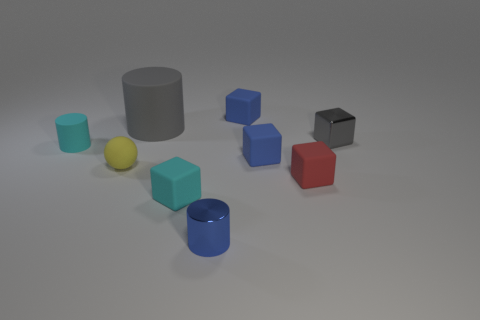Subtract all small gray metallic blocks. How many blocks are left? 4 Subtract all blue cylinders. How many blue cubes are left? 2 Add 1 yellow balls. How many objects exist? 10 Subtract all red blocks. How many blocks are left? 4 Subtract all brown cylinders. Subtract all purple balls. How many cylinders are left? 3 Subtract all cubes. How many objects are left? 4 Subtract all small cyan matte objects. Subtract all blue matte things. How many objects are left? 5 Add 7 blue metallic cylinders. How many blue metallic cylinders are left? 8 Add 7 yellow rubber objects. How many yellow rubber objects exist? 8 Subtract 0 brown cylinders. How many objects are left? 9 